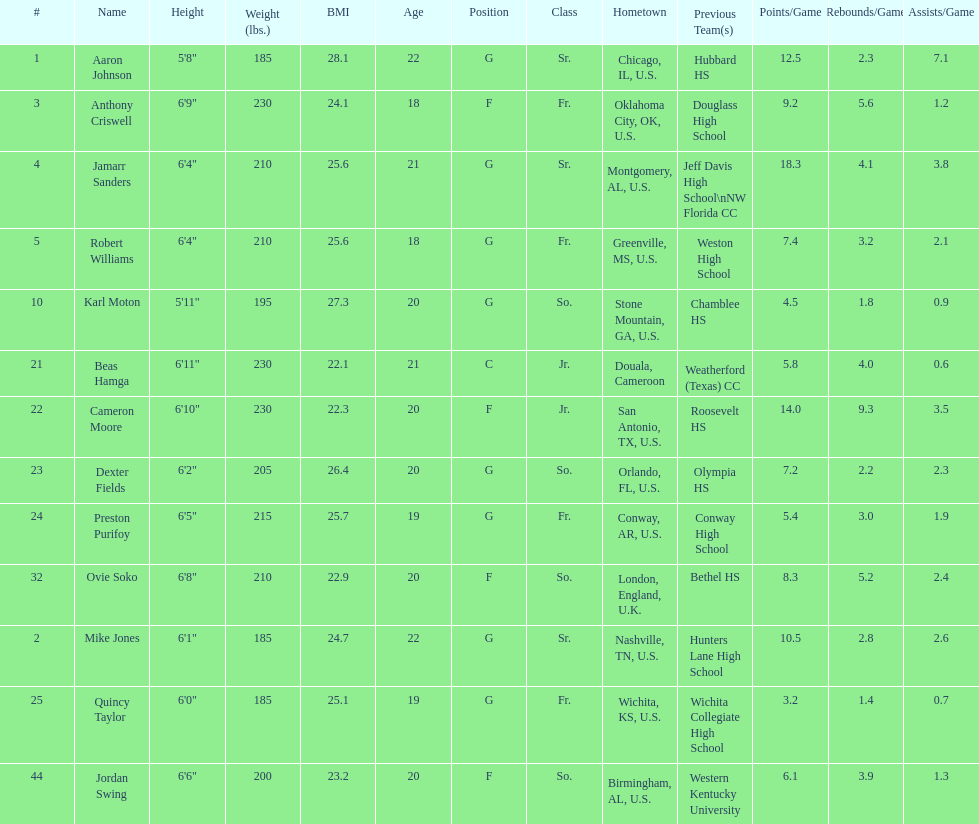Tell me the number of juniors on the team. 2. 